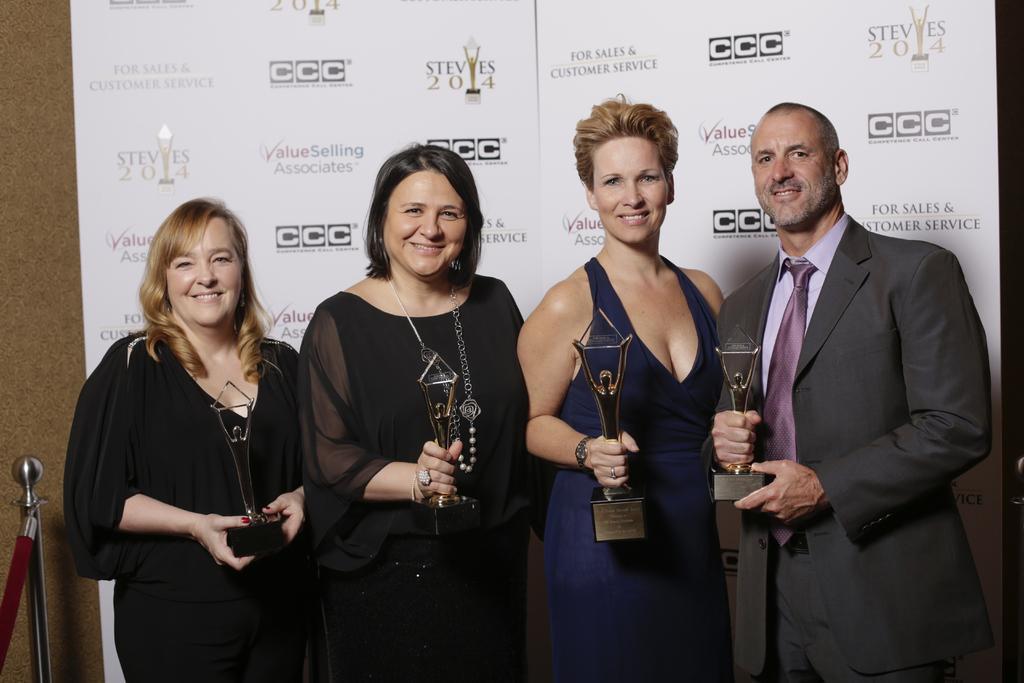Please provide a concise description of this image. This picture consists of a three women they are holding a memento and a man holding a memento and they are smiling and back side of them I can see the wall , on the wall I can see hoarding board attached and I can see stand on the left side. 